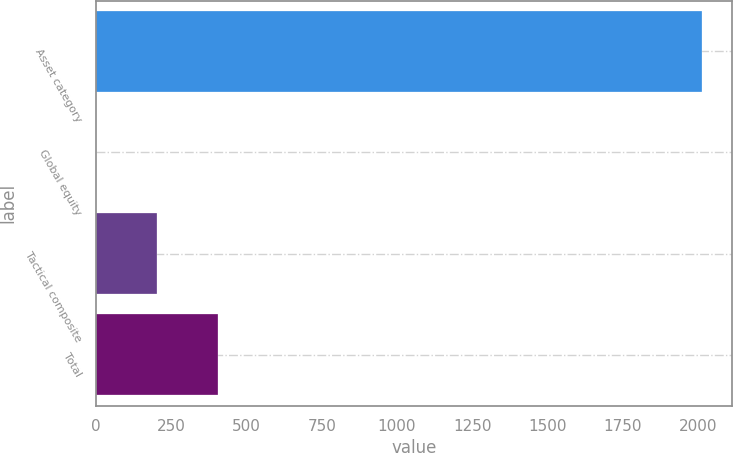Convert chart. <chart><loc_0><loc_0><loc_500><loc_500><bar_chart><fcel>Asset category<fcel>Global equity<fcel>Tactical composite<fcel>Total<nl><fcel>2013<fcel>1.1<fcel>202.29<fcel>403.48<nl></chart> 